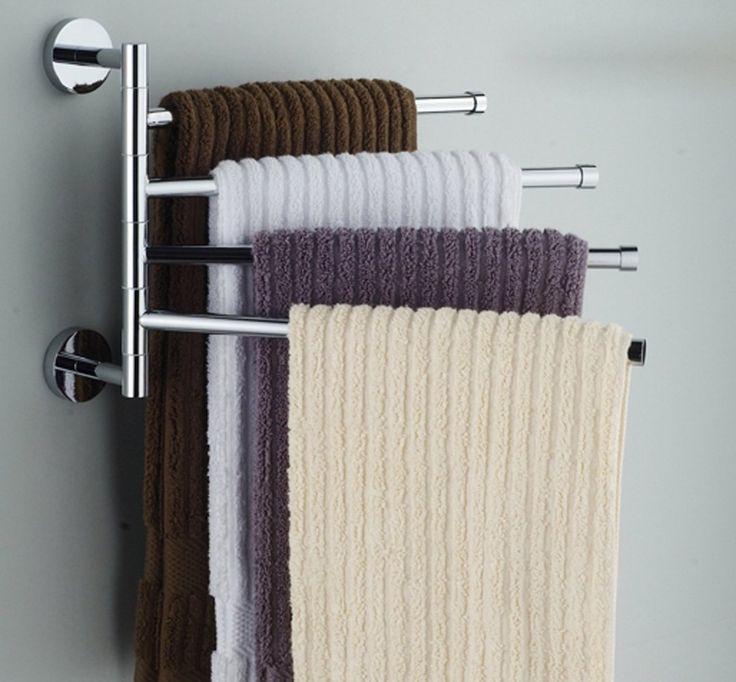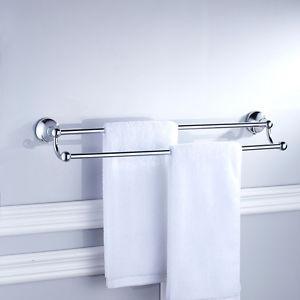The first image is the image on the left, the second image is the image on the right. Assess this claim about the two images: "In one image, three white towels are arranged on a three-tiered chrome bathroom rack.". Correct or not? Answer yes or no. No. 